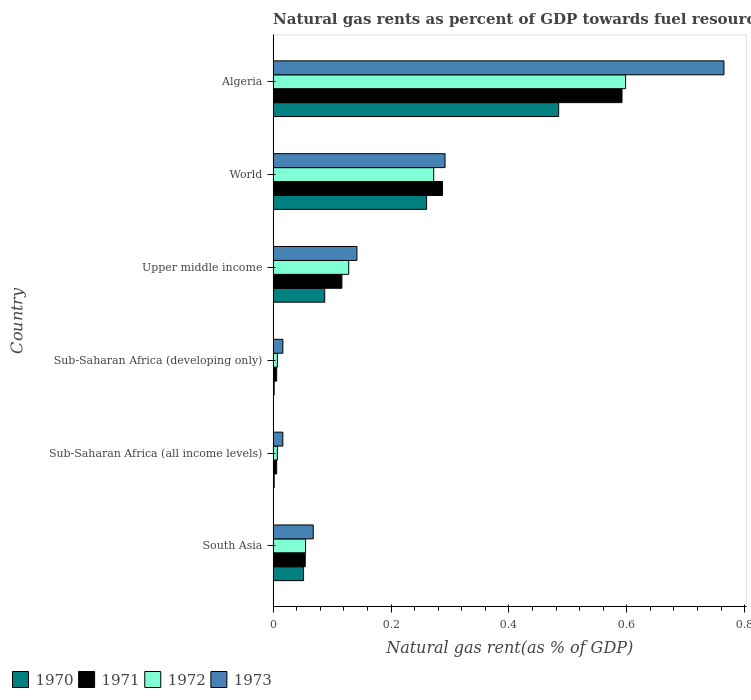How many different coloured bars are there?
Your answer should be very brief. 4. How many groups of bars are there?
Offer a very short reply. 6. How many bars are there on the 1st tick from the bottom?
Offer a terse response. 4. What is the label of the 5th group of bars from the top?
Offer a very short reply. Sub-Saharan Africa (all income levels). In how many cases, is the number of bars for a given country not equal to the number of legend labels?
Offer a terse response. 0. What is the natural gas rent in 1972 in Algeria?
Give a very brief answer. 0.6. Across all countries, what is the maximum natural gas rent in 1971?
Offer a terse response. 0.59. Across all countries, what is the minimum natural gas rent in 1972?
Offer a terse response. 0.01. In which country was the natural gas rent in 1973 maximum?
Provide a succinct answer. Algeria. In which country was the natural gas rent in 1971 minimum?
Offer a very short reply. Sub-Saharan Africa (all income levels). What is the total natural gas rent in 1972 in the graph?
Keep it short and to the point. 1.07. What is the difference between the natural gas rent in 1973 in Algeria and that in South Asia?
Your answer should be very brief. 0.7. What is the difference between the natural gas rent in 1973 in Sub-Saharan Africa (developing only) and the natural gas rent in 1972 in Algeria?
Ensure brevity in your answer.  -0.58. What is the average natural gas rent in 1972 per country?
Keep it short and to the point. 0.18. What is the difference between the natural gas rent in 1971 and natural gas rent in 1972 in South Asia?
Offer a terse response. -0. What is the ratio of the natural gas rent in 1971 in Algeria to that in Upper middle income?
Ensure brevity in your answer.  5.07. Is the natural gas rent in 1972 in South Asia less than that in Sub-Saharan Africa (developing only)?
Your answer should be compact. No. Is the difference between the natural gas rent in 1971 in Upper middle income and World greater than the difference between the natural gas rent in 1972 in Upper middle income and World?
Offer a very short reply. No. What is the difference between the highest and the second highest natural gas rent in 1973?
Keep it short and to the point. 0.47. What is the difference between the highest and the lowest natural gas rent in 1973?
Ensure brevity in your answer.  0.75. In how many countries, is the natural gas rent in 1972 greater than the average natural gas rent in 1972 taken over all countries?
Your answer should be compact. 2. Is it the case that in every country, the sum of the natural gas rent in 1973 and natural gas rent in 1970 is greater than the natural gas rent in 1971?
Give a very brief answer. Yes. Are all the bars in the graph horizontal?
Offer a terse response. Yes. What is the difference between two consecutive major ticks on the X-axis?
Your answer should be very brief. 0.2. How many legend labels are there?
Provide a succinct answer. 4. What is the title of the graph?
Give a very brief answer. Natural gas rents as percent of GDP towards fuel resources. What is the label or title of the X-axis?
Offer a terse response. Natural gas rent(as % of GDP). What is the Natural gas rent(as % of GDP) of 1970 in South Asia?
Your response must be concise. 0.05. What is the Natural gas rent(as % of GDP) in 1971 in South Asia?
Keep it short and to the point. 0.05. What is the Natural gas rent(as % of GDP) in 1972 in South Asia?
Your response must be concise. 0.06. What is the Natural gas rent(as % of GDP) of 1973 in South Asia?
Ensure brevity in your answer.  0.07. What is the Natural gas rent(as % of GDP) in 1970 in Sub-Saharan Africa (all income levels)?
Ensure brevity in your answer.  0. What is the Natural gas rent(as % of GDP) of 1971 in Sub-Saharan Africa (all income levels)?
Keep it short and to the point. 0.01. What is the Natural gas rent(as % of GDP) of 1972 in Sub-Saharan Africa (all income levels)?
Offer a terse response. 0.01. What is the Natural gas rent(as % of GDP) in 1973 in Sub-Saharan Africa (all income levels)?
Make the answer very short. 0.02. What is the Natural gas rent(as % of GDP) in 1970 in Sub-Saharan Africa (developing only)?
Make the answer very short. 0. What is the Natural gas rent(as % of GDP) in 1971 in Sub-Saharan Africa (developing only)?
Provide a succinct answer. 0.01. What is the Natural gas rent(as % of GDP) of 1972 in Sub-Saharan Africa (developing only)?
Your response must be concise. 0.01. What is the Natural gas rent(as % of GDP) in 1973 in Sub-Saharan Africa (developing only)?
Your response must be concise. 0.02. What is the Natural gas rent(as % of GDP) of 1970 in Upper middle income?
Offer a terse response. 0.09. What is the Natural gas rent(as % of GDP) of 1971 in Upper middle income?
Make the answer very short. 0.12. What is the Natural gas rent(as % of GDP) of 1972 in Upper middle income?
Give a very brief answer. 0.13. What is the Natural gas rent(as % of GDP) in 1973 in Upper middle income?
Offer a terse response. 0.14. What is the Natural gas rent(as % of GDP) of 1970 in World?
Offer a very short reply. 0.26. What is the Natural gas rent(as % of GDP) of 1971 in World?
Ensure brevity in your answer.  0.29. What is the Natural gas rent(as % of GDP) in 1972 in World?
Your response must be concise. 0.27. What is the Natural gas rent(as % of GDP) of 1973 in World?
Provide a short and direct response. 0.29. What is the Natural gas rent(as % of GDP) of 1970 in Algeria?
Provide a succinct answer. 0.48. What is the Natural gas rent(as % of GDP) of 1971 in Algeria?
Your answer should be very brief. 0.59. What is the Natural gas rent(as % of GDP) in 1972 in Algeria?
Keep it short and to the point. 0.6. What is the Natural gas rent(as % of GDP) in 1973 in Algeria?
Ensure brevity in your answer.  0.76. Across all countries, what is the maximum Natural gas rent(as % of GDP) of 1970?
Your answer should be very brief. 0.48. Across all countries, what is the maximum Natural gas rent(as % of GDP) of 1971?
Provide a short and direct response. 0.59. Across all countries, what is the maximum Natural gas rent(as % of GDP) of 1972?
Provide a succinct answer. 0.6. Across all countries, what is the maximum Natural gas rent(as % of GDP) of 1973?
Offer a terse response. 0.76. Across all countries, what is the minimum Natural gas rent(as % of GDP) in 1970?
Your answer should be very brief. 0. Across all countries, what is the minimum Natural gas rent(as % of GDP) of 1971?
Provide a short and direct response. 0.01. Across all countries, what is the minimum Natural gas rent(as % of GDP) of 1972?
Make the answer very short. 0.01. Across all countries, what is the minimum Natural gas rent(as % of GDP) of 1973?
Offer a very short reply. 0.02. What is the total Natural gas rent(as % of GDP) of 1970 in the graph?
Your answer should be very brief. 0.89. What is the total Natural gas rent(as % of GDP) in 1971 in the graph?
Your answer should be very brief. 1.06. What is the total Natural gas rent(as % of GDP) of 1972 in the graph?
Make the answer very short. 1.07. What is the total Natural gas rent(as % of GDP) in 1973 in the graph?
Ensure brevity in your answer.  1.3. What is the difference between the Natural gas rent(as % of GDP) in 1970 in South Asia and that in Sub-Saharan Africa (all income levels)?
Offer a very short reply. 0.05. What is the difference between the Natural gas rent(as % of GDP) in 1971 in South Asia and that in Sub-Saharan Africa (all income levels)?
Make the answer very short. 0.05. What is the difference between the Natural gas rent(as % of GDP) of 1972 in South Asia and that in Sub-Saharan Africa (all income levels)?
Ensure brevity in your answer.  0.05. What is the difference between the Natural gas rent(as % of GDP) in 1973 in South Asia and that in Sub-Saharan Africa (all income levels)?
Ensure brevity in your answer.  0.05. What is the difference between the Natural gas rent(as % of GDP) in 1970 in South Asia and that in Sub-Saharan Africa (developing only)?
Your answer should be very brief. 0.05. What is the difference between the Natural gas rent(as % of GDP) in 1971 in South Asia and that in Sub-Saharan Africa (developing only)?
Keep it short and to the point. 0.05. What is the difference between the Natural gas rent(as % of GDP) of 1972 in South Asia and that in Sub-Saharan Africa (developing only)?
Offer a very short reply. 0.05. What is the difference between the Natural gas rent(as % of GDP) of 1973 in South Asia and that in Sub-Saharan Africa (developing only)?
Your response must be concise. 0.05. What is the difference between the Natural gas rent(as % of GDP) of 1970 in South Asia and that in Upper middle income?
Provide a succinct answer. -0.04. What is the difference between the Natural gas rent(as % of GDP) in 1971 in South Asia and that in Upper middle income?
Your answer should be very brief. -0.06. What is the difference between the Natural gas rent(as % of GDP) in 1972 in South Asia and that in Upper middle income?
Keep it short and to the point. -0.07. What is the difference between the Natural gas rent(as % of GDP) of 1973 in South Asia and that in Upper middle income?
Your answer should be very brief. -0.07. What is the difference between the Natural gas rent(as % of GDP) of 1970 in South Asia and that in World?
Make the answer very short. -0.21. What is the difference between the Natural gas rent(as % of GDP) of 1971 in South Asia and that in World?
Give a very brief answer. -0.23. What is the difference between the Natural gas rent(as % of GDP) of 1972 in South Asia and that in World?
Give a very brief answer. -0.22. What is the difference between the Natural gas rent(as % of GDP) in 1973 in South Asia and that in World?
Your answer should be very brief. -0.22. What is the difference between the Natural gas rent(as % of GDP) in 1970 in South Asia and that in Algeria?
Offer a very short reply. -0.43. What is the difference between the Natural gas rent(as % of GDP) of 1971 in South Asia and that in Algeria?
Give a very brief answer. -0.54. What is the difference between the Natural gas rent(as % of GDP) in 1972 in South Asia and that in Algeria?
Provide a short and direct response. -0.54. What is the difference between the Natural gas rent(as % of GDP) in 1973 in South Asia and that in Algeria?
Provide a short and direct response. -0.7. What is the difference between the Natural gas rent(as % of GDP) of 1970 in Sub-Saharan Africa (all income levels) and that in Sub-Saharan Africa (developing only)?
Your answer should be very brief. -0. What is the difference between the Natural gas rent(as % of GDP) in 1973 in Sub-Saharan Africa (all income levels) and that in Sub-Saharan Africa (developing only)?
Provide a short and direct response. -0. What is the difference between the Natural gas rent(as % of GDP) in 1970 in Sub-Saharan Africa (all income levels) and that in Upper middle income?
Your response must be concise. -0.09. What is the difference between the Natural gas rent(as % of GDP) in 1971 in Sub-Saharan Africa (all income levels) and that in Upper middle income?
Keep it short and to the point. -0.11. What is the difference between the Natural gas rent(as % of GDP) of 1972 in Sub-Saharan Africa (all income levels) and that in Upper middle income?
Make the answer very short. -0.12. What is the difference between the Natural gas rent(as % of GDP) in 1973 in Sub-Saharan Africa (all income levels) and that in Upper middle income?
Ensure brevity in your answer.  -0.13. What is the difference between the Natural gas rent(as % of GDP) of 1970 in Sub-Saharan Africa (all income levels) and that in World?
Ensure brevity in your answer.  -0.26. What is the difference between the Natural gas rent(as % of GDP) in 1971 in Sub-Saharan Africa (all income levels) and that in World?
Keep it short and to the point. -0.28. What is the difference between the Natural gas rent(as % of GDP) in 1972 in Sub-Saharan Africa (all income levels) and that in World?
Your answer should be very brief. -0.27. What is the difference between the Natural gas rent(as % of GDP) in 1973 in Sub-Saharan Africa (all income levels) and that in World?
Your response must be concise. -0.28. What is the difference between the Natural gas rent(as % of GDP) in 1970 in Sub-Saharan Africa (all income levels) and that in Algeria?
Provide a succinct answer. -0.48. What is the difference between the Natural gas rent(as % of GDP) in 1971 in Sub-Saharan Africa (all income levels) and that in Algeria?
Make the answer very short. -0.59. What is the difference between the Natural gas rent(as % of GDP) of 1972 in Sub-Saharan Africa (all income levels) and that in Algeria?
Keep it short and to the point. -0.59. What is the difference between the Natural gas rent(as % of GDP) in 1973 in Sub-Saharan Africa (all income levels) and that in Algeria?
Provide a succinct answer. -0.75. What is the difference between the Natural gas rent(as % of GDP) of 1970 in Sub-Saharan Africa (developing only) and that in Upper middle income?
Your response must be concise. -0.09. What is the difference between the Natural gas rent(as % of GDP) of 1971 in Sub-Saharan Africa (developing only) and that in Upper middle income?
Provide a short and direct response. -0.11. What is the difference between the Natural gas rent(as % of GDP) of 1972 in Sub-Saharan Africa (developing only) and that in Upper middle income?
Give a very brief answer. -0.12. What is the difference between the Natural gas rent(as % of GDP) of 1973 in Sub-Saharan Africa (developing only) and that in Upper middle income?
Your response must be concise. -0.13. What is the difference between the Natural gas rent(as % of GDP) in 1970 in Sub-Saharan Africa (developing only) and that in World?
Keep it short and to the point. -0.26. What is the difference between the Natural gas rent(as % of GDP) in 1971 in Sub-Saharan Africa (developing only) and that in World?
Offer a very short reply. -0.28. What is the difference between the Natural gas rent(as % of GDP) of 1972 in Sub-Saharan Africa (developing only) and that in World?
Give a very brief answer. -0.27. What is the difference between the Natural gas rent(as % of GDP) of 1973 in Sub-Saharan Africa (developing only) and that in World?
Keep it short and to the point. -0.28. What is the difference between the Natural gas rent(as % of GDP) of 1970 in Sub-Saharan Africa (developing only) and that in Algeria?
Make the answer very short. -0.48. What is the difference between the Natural gas rent(as % of GDP) of 1971 in Sub-Saharan Africa (developing only) and that in Algeria?
Your answer should be very brief. -0.59. What is the difference between the Natural gas rent(as % of GDP) of 1972 in Sub-Saharan Africa (developing only) and that in Algeria?
Offer a terse response. -0.59. What is the difference between the Natural gas rent(as % of GDP) in 1973 in Sub-Saharan Africa (developing only) and that in Algeria?
Offer a very short reply. -0.75. What is the difference between the Natural gas rent(as % of GDP) in 1970 in Upper middle income and that in World?
Make the answer very short. -0.17. What is the difference between the Natural gas rent(as % of GDP) in 1971 in Upper middle income and that in World?
Offer a very short reply. -0.17. What is the difference between the Natural gas rent(as % of GDP) in 1972 in Upper middle income and that in World?
Give a very brief answer. -0.14. What is the difference between the Natural gas rent(as % of GDP) of 1973 in Upper middle income and that in World?
Ensure brevity in your answer.  -0.15. What is the difference between the Natural gas rent(as % of GDP) in 1970 in Upper middle income and that in Algeria?
Keep it short and to the point. -0.4. What is the difference between the Natural gas rent(as % of GDP) in 1971 in Upper middle income and that in Algeria?
Offer a very short reply. -0.48. What is the difference between the Natural gas rent(as % of GDP) of 1972 in Upper middle income and that in Algeria?
Your answer should be compact. -0.47. What is the difference between the Natural gas rent(as % of GDP) in 1973 in Upper middle income and that in Algeria?
Keep it short and to the point. -0.62. What is the difference between the Natural gas rent(as % of GDP) in 1970 in World and that in Algeria?
Your response must be concise. -0.22. What is the difference between the Natural gas rent(as % of GDP) of 1971 in World and that in Algeria?
Your response must be concise. -0.3. What is the difference between the Natural gas rent(as % of GDP) in 1972 in World and that in Algeria?
Give a very brief answer. -0.33. What is the difference between the Natural gas rent(as % of GDP) in 1973 in World and that in Algeria?
Give a very brief answer. -0.47. What is the difference between the Natural gas rent(as % of GDP) of 1970 in South Asia and the Natural gas rent(as % of GDP) of 1971 in Sub-Saharan Africa (all income levels)?
Your answer should be compact. 0.05. What is the difference between the Natural gas rent(as % of GDP) of 1970 in South Asia and the Natural gas rent(as % of GDP) of 1972 in Sub-Saharan Africa (all income levels)?
Provide a succinct answer. 0.04. What is the difference between the Natural gas rent(as % of GDP) in 1970 in South Asia and the Natural gas rent(as % of GDP) in 1973 in Sub-Saharan Africa (all income levels)?
Your answer should be compact. 0.04. What is the difference between the Natural gas rent(as % of GDP) in 1971 in South Asia and the Natural gas rent(as % of GDP) in 1972 in Sub-Saharan Africa (all income levels)?
Give a very brief answer. 0.05. What is the difference between the Natural gas rent(as % of GDP) in 1971 in South Asia and the Natural gas rent(as % of GDP) in 1973 in Sub-Saharan Africa (all income levels)?
Ensure brevity in your answer.  0.04. What is the difference between the Natural gas rent(as % of GDP) in 1972 in South Asia and the Natural gas rent(as % of GDP) in 1973 in Sub-Saharan Africa (all income levels)?
Make the answer very short. 0.04. What is the difference between the Natural gas rent(as % of GDP) of 1970 in South Asia and the Natural gas rent(as % of GDP) of 1971 in Sub-Saharan Africa (developing only)?
Provide a succinct answer. 0.05. What is the difference between the Natural gas rent(as % of GDP) of 1970 in South Asia and the Natural gas rent(as % of GDP) of 1972 in Sub-Saharan Africa (developing only)?
Make the answer very short. 0.04. What is the difference between the Natural gas rent(as % of GDP) in 1970 in South Asia and the Natural gas rent(as % of GDP) in 1973 in Sub-Saharan Africa (developing only)?
Offer a terse response. 0.04. What is the difference between the Natural gas rent(as % of GDP) in 1971 in South Asia and the Natural gas rent(as % of GDP) in 1972 in Sub-Saharan Africa (developing only)?
Your answer should be very brief. 0.05. What is the difference between the Natural gas rent(as % of GDP) in 1971 in South Asia and the Natural gas rent(as % of GDP) in 1973 in Sub-Saharan Africa (developing only)?
Ensure brevity in your answer.  0.04. What is the difference between the Natural gas rent(as % of GDP) of 1972 in South Asia and the Natural gas rent(as % of GDP) of 1973 in Sub-Saharan Africa (developing only)?
Provide a short and direct response. 0.04. What is the difference between the Natural gas rent(as % of GDP) of 1970 in South Asia and the Natural gas rent(as % of GDP) of 1971 in Upper middle income?
Your answer should be compact. -0.07. What is the difference between the Natural gas rent(as % of GDP) of 1970 in South Asia and the Natural gas rent(as % of GDP) of 1972 in Upper middle income?
Make the answer very short. -0.08. What is the difference between the Natural gas rent(as % of GDP) of 1970 in South Asia and the Natural gas rent(as % of GDP) of 1973 in Upper middle income?
Ensure brevity in your answer.  -0.09. What is the difference between the Natural gas rent(as % of GDP) of 1971 in South Asia and the Natural gas rent(as % of GDP) of 1972 in Upper middle income?
Your response must be concise. -0.07. What is the difference between the Natural gas rent(as % of GDP) in 1971 in South Asia and the Natural gas rent(as % of GDP) in 1973 in Upper middle income?
Your answer should be very brief. -0.09. What is the difference between the Natural gas rent(as % of GDP) in 1972 in South Asia and the Natural gas rent(as % of GDP) in 1973 in Upper middle income?
Your answer should be compact. -0.09. What is the difference between the Natural gas rent(as % of GDP) of 1970 in South Asia and the Natural gas rent(as % of GDP) of 1971 in World?
Keep it short and to the point. -0.24. What is the difference between the Natural gas rent(as % of GDP) in 1970 in South Asia and the Natural gas rent(as % of GDP) in 1972 in World?
Your answer should be compact. -0.22. What is the difference between the Natural gas rent(as % of GDP) in 1970 in South Asia and the Natural gas rent(as % of GDP) in 1973 in World?
Your response must be concise. -0.24. What is the difference between the Natural gas rent(as % of GDP) of 1971 in South Asia and the Natural gas rent(as % of GDP) of 1972 in World?
Your response must be concise. -0.22. What is the difference between the Natural gas rent(as % of GDP) of 1971 in South Asia and the Natural gas rent(as % of GDP) of 1973 in World?
Keep it short and to the point. -0.24. What is the difference between the Natural gas rent(as % of GDP) of 1972 in South Asia and the Natural gas rent(as % of GDP) of 1973 in World?
Offer a very short reply. -0.24. What is the difference between the Natural gas rent(as % of GDP) in 1970 in South Asia and the Natural gas rent(as % of GDP) in 1971 in Algeria?
Your answer should be very brief. -0.54. What is the difference between the Natural gas rent(as % of GDP) of 1970 in South Asia and the Natural gas rent(as % of GDP) of 1972 in Algeria?
Make the answer very short. -0.55. What is the difference between the Natural gas rent(as % of GDP) of 1970 in South Asia and the Natural gas rent(as % of GDP) of 1973 in Algeria?
Offer a very short reply. -0.71. What is the difference between the Natural gas rent(as % of GDP) in 1971 in South Asia and the Natural gas rent(as % of GDP) in 1972 in Algeria?
Your answer should be compact. -0.54. What is the difference between the Natural gas rent(as % of GDP) in 1971 in South Asia and the Natural gas rent(as % of GDP) in 1973 in Algeria?
Give a very brief answer. -0.71. What is the difference between the Natural gas rent(as % of GDP) in 1972 in South Asia and the Natural gas rent(as % of GDP) in 1973 in Algeria?
Keep it short and to the point. -0.71. What is the difference between the Natural gas rent(as % of GDP) in 1970 in Sub-Saharan Africa (all income levels) and the Natural gas rent(as % of GDP) in 1971 in Sub-Saharan Africa (developing only)?
Offer a very short reply. -0. What is the difference between the Natural gas rent(as % of GDP) of 1970 in Sub-Saharan Africa (all income levels) and the Natural gas rent(as % of GDP) of 1972 in Sub-Saharan Africa (developing only)?
Provide a short and direct response. -0.01. What is the difference between the Natural gas rent(as % of GDP) in 1970 in Sub-Saharan Africa (all income levels) and the Natural gas rent(as % of GDP) in 1973 in Sub-Saharan Africa (developing only)?
Your answer should be compact. -0.01. What is the difference between the Natural gas rent(as % of GDP) of 1971 in Sub-Saharan Africa (all income levels) and the Natural gas rent(as % of GDP) of 1972 in Sub-Saharan Africa (developing only)?
Offer a very short reply. -0. What is the difference between the Natural gas rent(as % of GDP) of 1971 in Sub-Saharan Africa (all income levels) and the Natural gas rent(as % of GDP) of 1973 in Sub-Saharan Africa (developing only)?
Make the answer very short. -0.01. What is the difference between the Natural gas rent(as % of GDP) of 1972 in Sub-Saharan Africa (all income levels) and the Natural gas rent(as % of GDP) of 1973 in Sub-Saharan Africa (developing only)?
Your answer should be compact. -0.01. What is the difference between the Natural gas rent(as % of GDP) in 1970 in Sub-Saharan Africa (all income levels) and the Natural gas rent(as % of GDP) in 1971 in Upper middle income?
Your answer should be compact. -0.11. What is the difference between the Natural gas rent(as % of GDP) in 1970 in Sub-Saharan Africa (all income levels) and the Natural gas rent(as % of GDP) in 1972 in Upper middle income?
Provide a short and direct response. -0.13. What is the difference between the Natural gas rent(as % of GDP) of 1970 in Sub-Saharan Africa (all income levels) and the Natural gas rent(as % of GDP) of 1973 in Upper middle income?
Make the answer very short. -0.14. What is the difference between the Natural gas rent(as % of GDP) in 1971 in Sub-Saharan Africa (all income levels) and the Natural gas rent(as % of GDP) in 1972 in Upper middle income?
Keep it short and to the point. -0.12. What is the difference between the Natural gas rent(as % of GDP) in 1971 in Sub-Saharan Africa (all income levels) and the Natural gas rent(as % of GDP) in 1973 in Upper middle income?
Offer a very short reply. -0.14. What is the difference between the Natural gas rent(as % of GDP) in 1972 in Sub-Saharan Africa (all income levels) and the Natural gas rent(as % of GDP) in 1973 in Upper middle income?
Your answer should be very brief. -0.14. What is the difference between the Natural gas rent(as % of GDP) in 1970 in Sub-Saharan Africa (all income levels) and the Natural gas rent(as % of GDP) in 1971 in World?
Provide a short and direct response. -0.29. What is the difference between the Natural gas rent(as % of GDP) of 1970 in Sub-Saharan Africa (all income levels) and the Natural gas rent(as % of GDP) of 1972 in World?
Provide a succinct answer. -0.27. What is the difference between the Natural gas rent(as % of GDP) of 1970 in Sub-Saharan Africa (all income levels) and the Natural gas rent(as % of GDP) of 1973 in World?
Give a very brief answer. -0.29. What is the difference between the Natural gas rent(as % of GDP) in 1971 in Sub-Saharan Africa (all income levels) and the Natural gas rent(as % of GDP) in 1972 in World?
Give a very brief answer. -0.27. What is the difference between the Natural gas rent(as % of GDP) in 1971 in Sub-Saharan Africa (all income levels) and the Natural gas rent(as % of GDP) in 1973 in World?
Keep it short and to the point. -0.29. What is the difference between the Natural gas rent(as % of GDP) in 1972 in Sub-Saharan Africa (all income levels) and the Natural gas rent(as % of GDP) in 1973 in World?
Keep it short and to the point. -0.28. What is the difference between the Natural gas rent(as % of GDP) of 1970 in Sub-Saharan Africa (all income levels) and the Natural gas rent(as % of GDP) of 1971 in Algeria?
Offer a very short reply. -0.59. What is the difference between the Natural gas rent(as % of GDP) in 1970 in Sub-Saharan Africa (all income levels) and the Natural gas rent(as % of GDP) in 1972 in Algeria?
Offer a very short reply. -0.6. What is the difference between the Natural gas rent(as % of GDP) of 1970 in Sub-Saharan Africa (all income levels) and the Natural gas rent(as % of GDP) of 1973 in Algeria?
Offer a very short reply. -0.76. What is the difference between the Natural gas rent(as % of GDP) in 1971 in Sub-Saharan Africa (all income levels) and the Natural gas rent(as % of GDP) in 1972 in Algeria?
Keep it short and to the point. -0.59. What is the difference between the Natural gas rent(as % of GDP) in 1971 in Sub-Saharan Africa (all income levels) and the Natural gas rent(as % of GDP) in 1973 in Algeria?
Give a very brief answer. -0.76. What is the difference between the Natural gas rent(as % of GDP) of 1972 in Sub-Saharan Africa (all income levels) and the Natural gas rent(as % of GDP) of 1973 in Algeria?
Provide a succinct answer. -0.76. What is the difference between the Natural gas rent(as % of GDP) in 1970 in Sub-Saharan Africa (developing only) and the Natural gas rent(as % of GDP) in 1971 in Upper middle income?
Your response must be concise. -0.11. What is the difference between the Natural gas rent(as % of GDP) in 1970 in Sub-Saharan Africa (developing only) and the Natural gas rent(as % of GDP) in 1972 in Upper middle income?
Your response must be concise. -0.13. What is the difference between the Natural gas rent(as % of GDP) of 1970 in Sub-Saharan Africa (developing only) and the Natural gas rent(as % of GDP) of 1973 in Upper middle income?
Offer a very short reply. -0.14. What is the difference between the Natural gas rent(as % of GDP) in 1971 in Sub-Saharan Africa (developing only) and the Natural gas rent(as % of GDP) in 1972 in Upper middle income?
Make the answer very short. -0.12. What is the difference between the Natural gas rent(as % of GDP) in 1971 in Sub-Saharan Africa (developing only) and the Natural gas rent(as % of GDP) in 1973 in Upper middle income?
Make the answer very short. -0.14. What is the difference between the Natural gas rent(as % of GDP) of 1972 in Sub-Saharan Africa (developing only) and the Natural gas rent(as % of GDP) of 1973 in Upper middle income?
Provide a short and direct response. -0.14. What is the difference between the Natural gas rent(as % of GDP) in 1970 in Sub-Saharan Africa (developing only) and the Natural gas rent(as % of GDP) in 1971 in World?
Make the answer very short. -0.29. What is the difference between the Natural gas rent(as % of GDP) in 1970 in Sub-Saharan Africa (developing only) and the Natural gas rent(as % of GDP) in 1972 in World?
Keep it short and to the point. -0.27. What is the difference between the Natural gas rent(as % of GDP) of 1970 in Sub-Saharan Africa (developing only) and the Natural gas rent(as % of GDP) of 1973 in World?
Keep it short and to the point. -0.29. What is the difference between the Natural gas rent(as % of GDP) of 1971 in Sub-Saharan Africa (developing only) and the Natural gas rent(as % of GDP) of 1972 in World?
Give a very brief answer. -0.27. What is the difference between the Natural gas rent(as % of GDP) in 1971 in Sub-Saharan Africa (developing only) and the Natural gas rent(as % of GDP) in 1973 in World?
Give a very brief answer. -0.29. What is the difference between the Natural gas rent(as % of GDP) of 1972 in Sub-Saharan Africa (developing only) and the Natural gas rent(as % of GDP) of 1973 in World?
Provide a succinct answer. -0.28. What is the difference between the Natural gas rent(as % of GDP) of 1970 in Sub-Saharan Africa (developing only) and the Natural gas rent(as % of GDP) of 1971 in Algeria?
Provide a succinct answer. -0.59. What is the difference between the Natural gas rent(as % of GDP) of 1970 in Sub-Saharan Africa (developing only) and the Natural gas rent(as % of GDP) of 1972 in Algeria?
Make the answer very short. -0.6. What is the difference between the Natural gas rent(as % of GDP) in 1970 in Sub-Saharan Africa (developing only) and the Natural gas rent(as % of GDP) in 1973 in Algeria?
Offer a very short reply. -0.76. What is the difference between the Natural gas rent(as % of GDP) of 1971 in Sub-Saharan Africa (developing only) and the Natural gas rent(as % of GDP) of 1972 in Algeria?
Provide a short and direct response. -0.59. What is the difference between the Natural gas rent(as % of GDP) of 1971 in Sub-Saharan Africa (developing only) and the Natural gas rent(as % of GDP) of 1973 in Algeria?
Your answer should be compact. -0.76. What is the difference between the Natural gas rent(as % of GDP) of 1972 in Sub-Saharan Africa (developing only) and the Natural gas rent(as % of GDP) of 1973 in Algeria?
Provide a short and direct response. -0.76. What is the difference between the Natural gas rent(as % of GDP) in 1970 in Upper middle income and the Natural gas rent(as % of GDP) in 1971 in World?
Ensure brevity in your answer.  -0.2. What is the difference between the Natural gas rent(as % of GDP) in 1970 in Upper middle income and the Natural gas rent(as % of GDP) in 1972 in World?
Give a very brief answer. -0.18. What is the difference between the Natural gas rent(as % of GDP) of 1970 in Upper middle income and the Natural gas rent(as % of GDP) of 1973 in World?
Provide a short and direct response. -0.2. What is the difference between the Natural gas rent(as % of GDP) of 1971 in Upper middle income and the Natural gas rent(as % of GDP) of 1972 in World?
Your answer should be compact. -0.16. What is the difference between the Natural gas rent(as % of GDP) in 1971 in Upper middle income and the Natural gas rent(as % of GDP) in 1973 in World?
Your answer should be compact. -0.17. What is the difference between the Natural gas rent(as % of GDP) in 1972 in Upper middle income and the Natural gas rent(as % of GDP) in 1973 in World?
Provide a succinct answer. -0.16. What is the difference between the Natural gas rent(as % of GDP) in 1970 in Upper middle income and the Natural gas rent(as % of GDP) in 1971 in Algeria?
Your answer should be very brief. -0.5. What is the difference between the Natural gas rent(as % of GDP) of 1970 in Upper middle income and the Natural gas rent(as % of GDP) of 1972 in Algeria?
Your response must be concise. -0.51. What is the difference between the Natural gas rent(as % of GDP) in 1970 in Upper middle income and the Natural gas rent(as % of GDP) in 1973 in Algeria?
Give a very brief answer. -0.68. What is the difference between the Natural gas rent(as % of GDP) of 1971 in Upper middle income and the Natural gas rent(as % of GDP) of 1972 in Algeria?
Provide a short and direct response. -0.48. What is the difference between the Natural gas rent(as % of GDP) in 1971 in Upper middle income and the Natural gas rent(as % of GDP) in 1973 in Algeria?
Your answer should be very brief. -0.65. What is the difference between the Natural gas rent(as % of GDP) of 1972 in Upper middle income and the Natural gas rent(as % of GDP) of 1973 in Algeria?
Your answer should be very brief. -0.64. What is the difference between the Natural gas rent(as % of GDP) of 1970 in World and the Natural gas rent(as % of GDP) of 1971 in Algeria?
Make the answer very short. -0.33. What is the difference between the Natural gas rent(as % of GDP) in 1970 in World and the Natural gas rent(as % of GDP) in 1972 in Algeria?
Give a very brief answer. -0.34. What is the difference between the Natural gas rent(as % of GDP) of 1970 in World and the Natural gas rent(as % of GDP) of 1973 in Algeria?
Your answer should be compact. -0.5. What is the difference between the Natural gas rent(as % of GDP) in 1971 in World and the Natural gas rent(as % of GDP) in 1972 in Algeria?
Provide a short and direct response. -0.31. What is the difference between the Natural gas rent(as % of GDP) in 1971 in World and the Natural gas rent(as % of GDP) in 1973 in Algeria?
Make the answer very short. -0.48. What is the difference between the Natural gas rent(as % of GDP) of 1972 in World and the Natural gas rent(as % of GDP) of 1973 in Algeria?
Provide a succinct answer. -0.49. What is the average Natural gas rent(as % of GDP) in 1970 per country?
Offer a terse response. 0.15. What is the average Natural gas rent(as % of GDP) of 1971 per country?
Your answer should be very brief. 0.18. What is the average Natural gas rent(as % of GDP) of 1972 per country?
Offer a terse response. 0.18. What is the average Natural gas rent(as % of GDP) of 1973 per country?
Ensure brevity in your answer.  0.22. What is the difference between the Natural gas rent(as % of GDP) of 1970 and Natural gas rent(as % of GDP) of 1971 in South Asia?
Provide a succinct answer. -0. What is the difference between the Natural gas rent(as % of GDP) of 1970 and Natural gas rent(as % of GDP) of 1972 in South Asia?
Provide a short and direct response. -0. What is the difference between the Natural gas rent(as % of GDP) in 1970 and Natural gas rent(as % of GDP) in 1973 in South Asia?
Keep it short and to the point. -0.02. What is the difference between the Natural gas rent(as % of GDP) in 1971 and Natural gas rent(as % of GDP) in 1972 in South Asia?
Give a very brief answer. -0. What is the difference between the Natural gas rent(as % of GDP) of 1971 and Natural gas rent(as % of GDP) of 1973 in South Asia?
Make the answer very short. -0.01. What is the difference between the Natural gas rent(as % of GDP) of 1972 and Natural gas rent(as % of GDP) of 1973 in South Asia?
Provide a short and direct response. -0.01. What is the difference between the Natural gas rent(as % of GDP) of 1970 and Natural gas rent(as % of GDP) of 1971 in Sub-Saharan Africa (all income levels)?
Your answer should be compact. -0. What is the difference between the Natural gas rent(as % of GDP) in 1970 and Natural gas rent(as % of GDP) in 1972 in Sub-Saharan Africa (all income levels)?
Ensure brevity in your answer.  -0.01. What is the difference between the Natural gas rent(as % of GDP) of 1970 and Natural gas rent(as % of GDP) of 1973 in Sub-Saharan Africa (all income levels)?
Ensure brevity in your answer.  -0.01. What is the difference between the Natural gas rent(as % of GDP) of 1971 and Natural gas rent(as % of GDP) of 1972 in Sub-Saharan Africa (all income levels)?
Ensure brevity in your answer.  -0. What is the difference between the Natural gas rent(as % of GDP) of 1971 and Natural gas rent(as % of GDP) of 1973 in Sub-Saharan Africa (all income levels)?
Make the answer very short. -0.01. What is the difference between the Natural gas rent(as % of GDP) in 1972 and Natural gas rent(as % of GDP) in 1973 in Sub-Saharan Africa (all income levels)?
Your answer should be very brief. -0.01. What is the difference between the Natural gas rent(as % of GDP) in 1970 and Natural gas rent(as % of GDP) in 1971 in Sub-Saharan Africa (developing only)?
Your answer should be very brief. -0. What is the difference between the Natural gas rent(as % of GDP) of 1970 and Natural gas rent(as % of GDP) of 1972 in Sub-Saharan Africa (developing only)?
Offer a very short reply. -0.01. What is the difference between the Natural gas rent(as % of GDP) in 1970 and Natural gas rent(as % of GDP) in 1973 in Sub-Saharan Africa (developing only)?
Offer a very short reply. -0.01. What is the difference between the Natural gas rent(as % of GDP) in 1971 and Natural gas rent(as % of GDP) in 1972 in Sub-Saharan Africa (developing only)?
Your answer should be very brief. -0. What is the difference between the Natural gas rent(as % of GDP) in 1971 and Natural gas rent(as % of GDP) in 1973 in Sub-Saharan Africa (developing only)?
Keep it short and to the point. -0.01. What is the difference between the Natural gas rent(as % of GDP) in 1972 and Natural gas rent(as % of GDP) in 1973 in Sub-Saharan Africa (developing only)?
Keep it short and to the point. -0.01. What is the difference between the Natural gas rent(as % of GDP) of 1970 and Natural gas rent(as % of GDP) of 1971 in Upper middle income?
Offer a terse response. -0.03. What is the difference between the Natural gas rent(as % of GDP) of 1970 and Natural gas rent(as % of GDP) of 1972 in Upper middle income?
Your answer should be very brief. -0.04. What is the difference between the Natural gas rent(as % of GDP) of 1970 and Natural gas rent(as % of GDP) of 1973 in Upper middle income?
Your answer should be very brief. -0.05. What is the difference between the Natural gas rent(as % of GDP) in 1971 and Natural gas rent(as % of GDP) in 1972 in Upper middle income?
Provide a short and direct response. -0.01. What is the difference between the Natural gas rent(as % of GDP) in 1971 and Natural gas rent(as % of GDP) in 1973 in Upper middle income?
Your answer should be compact. -0.03. What is the difference between the Natural gas rent(as % of GDP) of 1972 and Natural gas rent(as % of GDP) of 1973 in Upper middle income?
Give a very brief answer. -0.01. What is the difference between the Natural gas rent(as % of GDP) of 1970 and Natural gas rent(as % of GDP) of 1971 in World?
Your answer should be compact. -0.03. What is the difference between the Natural gas rent(as % of GDP) in 1970 and Natural gas rent(as % of GDP) in 1972 in World?
Provide a succinct answer. -0.01. What is the difference between the Natural gas rent(as % of GDP) of 1970 and Natural gas rent(as % of GDP) of 1973 in World?
Your answer should be very brief. -0.03. What is the difference between the Natural gas rent(as % of GDP) in 1971 and Natural gas rent(as % of GDP) in 1972 in World?
Your answer should be very brief. 0.01. What is the difference between the Natural gas rent(as % of GDP) of 1971 and Natural gas rent(as % of GDP) of 1973 in World?
Give a very brief answer. -0. What is the difference between the Natural gas rent(as % of GDP) in 1972 and Natural gas rent(as % of GDP) in 1973 in World?
Provide a succinct answer. -0.02. What is the difference between the Natural gas rent(as % of GDP) of 1970 and Natural gas rent(as % of GDP) of 1971 in Algeria?
Provide a short and direct response. -0.11. What is the difference between the Natural gas rent(as % of GDP) in 1970 and Natural gas rent(as % of GDP) in 1972 in Algeria?
Keep it short and to the point. -0.11. What is the difference between the Natural gas rent(as % of GDP) of 1970 and Natural gas rent(as % of GDP) of 1973 in Algeria?
Provide a short and direct response. -0.28. What is the difference between the Natural gas rent(as % of GDP) in 1971 and Natural gas rent(as % of GDP) in 1972 in Algeria?
Make the answer very short. -0.01. What is the difference between the Natural gas rent(as % of GDP) in 1971 and Natural gas rent(as % of GDP) in 1973 in Algeria?
Provide a short and direct response. -0.17. What is the difference between the Natural gas rent(as % of GDP) of 1972 and Natural gas rent(as % of GDP) of 1973 in Algeria?
Offer a terse response. -0.17. What is the ratio of the Natural gas rent(as % of GDP) of 1970 in South Asia to that in Sub-Saharan Africa (all income levels)?
Your answer should be compact. 28.57. What is the ratio of the Natural gas rent(as % of GDP) of 1971 in South Asia to that in Sub-Saharan Africa (all income levels)?
Your response must be concise. 9.07. What is the ratio of the Natural gas rent(as % of GDP) in 1972 in South Asia to that in Sub-Saharan Africa (all income levels)?
Provide a short and direct response. 7.67. What is the ratio of the Natural gas rent(as % of GDP) in 1973 in South Asia to that in Sub-Saharan Africa (all income levels)?
Offer a terse response. 4.13. What is the ratio of the Natural gas rent(as % of GDP) in 1970 in South Asia to that in Sub-Saharan Africa (developing only)?
Offer a terse response. 28.53. What is the ratio of the Natural gas rent(as % of GDP) in 1971 in South Asia to that in Sub-Saharan Africa (developing only)?
Provide a short and direct response. 9.06. What is the ratio of the Natural gas rent(as % of GDP) of 1972 in South Asia to that in Sub-Saharan Africa (developing only)?
Ensure brevity in your answer.  7.66. What is the ratio of the Natural gas rent(as % of GDP) in 1973 in South Asia to that in Sub-Saharan Africa (developing only)?
Keep it short and to the point. 4.12. What is the ratio of the Natural gas rent(as % of GDP) of 1970 in South Asia to that in Upper middle income?
Give a very brief answer. 0.59. What is the ratio of the Natural gas rent(as % of GDP) of 1971 in South Asia to that in Upper middle income?
Offer a terse response. 0.47. What is the ratio of the Natural gas rent(as % of GDP) in 1972 in South Asia to that in Upper middle income?
Give a very brief answer. 0.43. What is the ratio of the Natural gas rent(as % of GDP) of 1973 in South Asia to that in Upper middle income?
Provide a short and direct response. 0.48. What is the ratio of the Natural gas rent(as % of GDP) of 1970 in South Asia to that in World?
Provide a short and direct response. 0.2. What is the ratio of the Natural gas rent(as % of GDP) in 1971 in South Asia to that in World?
Give a very brief answer. 0.19. What is the ratio of the Natural gas rent(as % of GDP) of 1972 in South Asia to that in World?
Your response must be concise. 0.2. What is the ratio of the Natural gas rent(as % of GDP) of 1973 in South Asia to that in World?
Provide a succinct answer. 0.23. What is the ratio of the Natural gas rent(as % of GDP) of 1970 in South Asia to that in Algeria?
Provide a short and direct response. 0.11. What is the ratio of the Natural gas rent(as % of GDP) of 1971 in South Asia to that in Algeria?
Offer a terse response. 0.09. What is the ratio of the Natural gas rent(as % of GDP) of 1972 in South Asia to that in Algeria?
Provide a short and direct response. 0.09. What is the ratio of the Natural gas rent(as % of GDP) of 1973 in South Asia to that in Algeria?
Offer a terse response. 0.09. What is the ratio of the Natural gas rent(as % of GDP) of 1972 in Sub-Saharan Africa (all income levels) to that in Sub-Saharan Africa (developing only)?
Ensure brevity in your answer.  1. What is the ratio of the Natural gas rent(as % of GDP) of 1970 in Sub-Saharan Africa (all income levels) to that in Upper middle income?
Give a very brief answer. 0.02. What is the ratio of the Natural gas rent(as % of GDP) in 1971 in Sub-Saharan Africa (all income levels) to that in Upper middle income?
Give a very brief answer. 0.05. What is the ratio of the Natural gas rent(as % of GDP) of 1972 in Sub-Saharan Africa (all income levels) to that in Upper middle income?
Make the answer very short. 0.06. What is the ratio of the Natural gas rent(as % of GDP) of 1973 in Sub-Saharan Africa (all income levels) to that in Upper middle income?
Provide a succinct answer. 0.12. What is the ratio of the Natural gas rent(as % of GDP) in 1970 in Sub-Saharan Africa (all income levels) to that in World?
Ensure brevity in your answer.  0.01. What is the ratio of the Natural gas rent(as % of GDP) of 1971 in Sub-Saharan Africa (all income levels) to that in World?
Offer a very short reply. 0.02. What is the ratio of the Natural gas rent(as % of GDP) in 1972 in Sub-Saharan Africa (all income levels) to that in World?
Offer a very short reply. 0.03. What is the ratio of the Natural gas rent(as % of GDP) of 1973 in Sub-Saharan Africa (all income levels) to that in World?
Give a very brief answer. 0.06. What is the ratio of the Natural gas rent(as % of GDP) of 1970 in Sub-Saharan Africa (all income levels) to that in Algeria?
Keep it short and to the point. 0. What is the ratio of the Natural gas rent(as % of GDP) of 1971 in Sub-Saharan Africa (all income levels) to that in Algeria?
Your answer should be very brief. 0.01. What is the ratio of the Natural gas rent(as % of GDP) of 1972 in Sub-Saharan Africa (all income levels) to that in Algeria?
Keep it short and to the point. 0.01. What is the ratio of the Natural gas rent(as % of GDP) in 1973 in Sub-Saharan Africa (all income levels) to that in Algeria?
Offer a very short reply. 0.02. What is the ratio of the Natural gas rent(as % of GDP) in 1970 in Sub-Saharan Africa (developing only) to that in Upper middle income?
Provide a short and direct response. 0.02. What is the ratio of the Natural gas rent(as % of GDP) in 1971 in Sub-Saharan Africa (developing only) to that in Upper middle income?
Make the answer very short. 0.05. What is the ratio of the Natural gas rent(as % of GDP) in 1972 in Sub-Saharan Africa (developing only) to that in Upper middle income?
Provide a succinct answer. 0.06. What is the ratio of the Natural gas rent(as % of GDP) of 1973 in Sub-Saharan Africa (developing only) to that in Upper middle income?
Provide a short and direct response. 0.12. What is the ratio of the Natural gas rent(as % of GDP) of 1970 in Sub-Saharan Africa (developing only) to that in World?
Your answer should be compact. 0.01. What is the ratio of the Natural gas rent(as % of GDP) in 1971 in Sub-Saharan Africa (developing only) to that in World?
Keep it short and to the point. 0.02. What is the ratio of the Natural gas rent(as % of GDP) in 1972 in Sub-Saharan Africa (developing only) to that in World?
Offer a terse response. 0.03. What is the ratio of the Natural gas rent(as % of GDP) in 1973 in Sub-Saharan Africa (developing only) to that in World?
Offer a very short reply. 0.06. What is the ratio of the Natural gas rent(as % of GDP) in 1970 in Sub-Saharan Africa (developing only) to that in Algeria?
Provide a short and direct response. 0. What is the ratio of the Natural gas rent(as % of GDP) in 1971 in Sub-Saharan Africa (developing only) to that in Algeria?
Your response must be concise. 0.01. What is the ratio of the Natural gas rent(as % of GDP) in 1972 in Sub-Saharan Africa (developing only) to that in Algeria?
Make the answer very short. 0.01. What is the ratio of the Natural gas rent(as % of GDP) of 1973 in Sub-Saharan Africa (developing only) to that in Algeria?
Give a very brief answer. 0.02. What is the ratio of the Natural gas rent(as % of GDP) of 1970 in Upper middle income to that in World?
Offer a very short reply. 0.34. What is the ratio of the Natural gas rent(as % of GDP) in 1971 in Upper middle income to that in World?
Make the answer very short. 0.41. What is the ratio of the Natural gas rent(as % of GDP) in 1972 in Upper middle income to that in World?
Offer a very short reply. 0.47. What is the ratio of the Natural gas rent(as % of GDP) in 1973 in Upper middle income to that in World?
Offer a terse response. 0.49. What is the ratio of the Natural gas rent(as % of GDP) of 1970 in Upper middle income to that in Algeria?
Give a very brief answer. 0.18. What is the ratio of the Natural gas rent(as % of GDP) of 1971 in Upper middle income to that in Algeria?
Offer a terse response. 0.2. What is the ratio of the Natural gas rent(as % of GDP) of 1972 in Upper middle income to that in Algeria?
Your response must be concise. 0.21. What is the ratio of the Natural gas rent(as % of GDP) of 1973 in Upper middle income to that in Algeria?
Keep it short and to the point. 0.19. What is the ratio of the Natural gas rent(as % of GDP) of 1970 in World to that in Algeria?
Your answer should be very brief. 0.54. What is the ratio of the Natural gas rent(as % of GDP) in 1971 in World to that in Algeria?
Make the answer very short. 0.49. What is the ratio of the Natural gas rent(as % of GDP) of 1972 in World to that in Algeria?
Your answer should be very brief. 0.46. What is the ratio of the Natural gas rent(as % of GDP) of 1973 in World to that in Algeria?
Your answer should be compact. 0.38. What is the difference between the highest and the second highest Natural gas rent(as % of GDP) in 1970?
Make the answer very short. 0.22. What is the difference between the highest and the second highest Natural gas rent(as % of GDP) in 1971?
Your answer should be very brief. 0.3. What is the difference between the highest and the second highest Natural gas rent(as % of GDP) of 1972?
Offer a very short reply. 0.33. What is the difference between the highest and the second highest Natural gas rent(as % of GDP) of 1973?
Your answer should be very brief. 0.47. What is the difference between the highest and the lowest Natural gas rent(as % of GDP) in 1970?
Give a very brief answer. 0.48. What is the difference between the highest and the lowest Natural gas rent(as % of GDP) in 1971?
Offer a terse response. 0.59. What is the difference between the highest and the lowest Natural gas rent(as % of GDP) in 1972?
Offer a very short reply. 0.59. What is the difference between the highest and the lowest Natural gas rent(as % of GDP) in 1973?
Offer a very short reply. 0.75. 